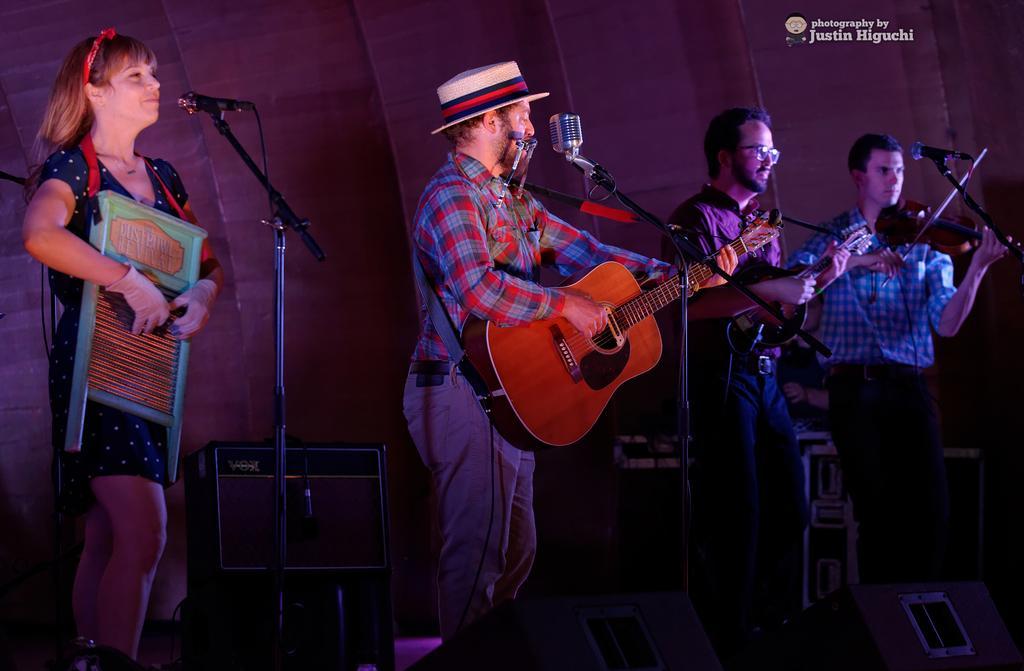How would you summarize this image in a sentence or two? 4 people are standing in front of microphone. the people at the right are playing violin, the person at the center is playing guitar and wearing a hat. 